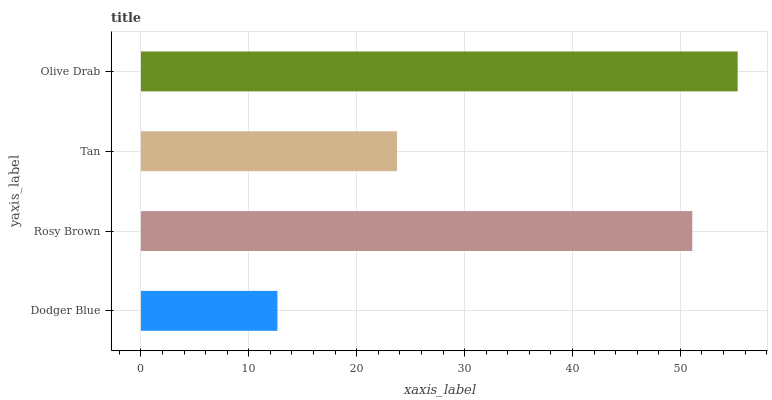Is Dodger Blue the minimum?
Answer yes or no. Yes. Is Olive Drab the maximum?
Answer yes or no. Yes. Is Rosy Brown the minimum?
Answer yes or no. No. Is Rosy Brown the maximum?
Answer yes or no. No. Is Rosy Brown greater than Dodger Blue?
Answer yes or no. Yes. Is Dodger Blue less than Rosy Brown?
Answer yes or no. Yes. Is Dodger Blue greater than Rosy Brown?
Answer yes or no. No. Is Rosy Brown less than Dodger Blue?
Answer yes or no. No. Is Rosy Brown the high median?
Answer yes or no. Yes. Is Tan the low median?
Answer yes or no. Yes. Is Dodger Blue the high median?
Answer yes or no. No. Is Rosy Brown the low median?
Answer yes or no. No. 